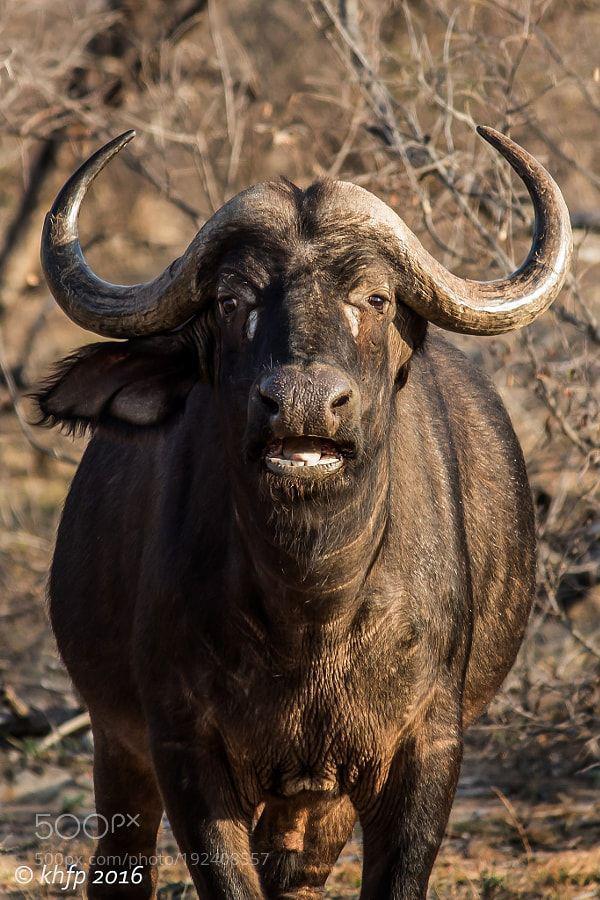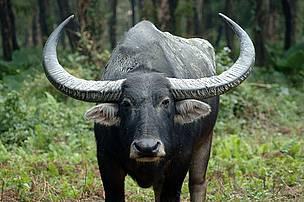The first image is the image on the left, the second image is the image on the right. For the images shown, is this caption "The big horned cow on the left is brown and not black." true? Answer yes or no. Yes. The first image is the image on the left, the second image is the image on the right. Given the left and right images, does the statement "There are exactly two animals who are facing in the same direction." hold true? Answer yes or no. Yes. 